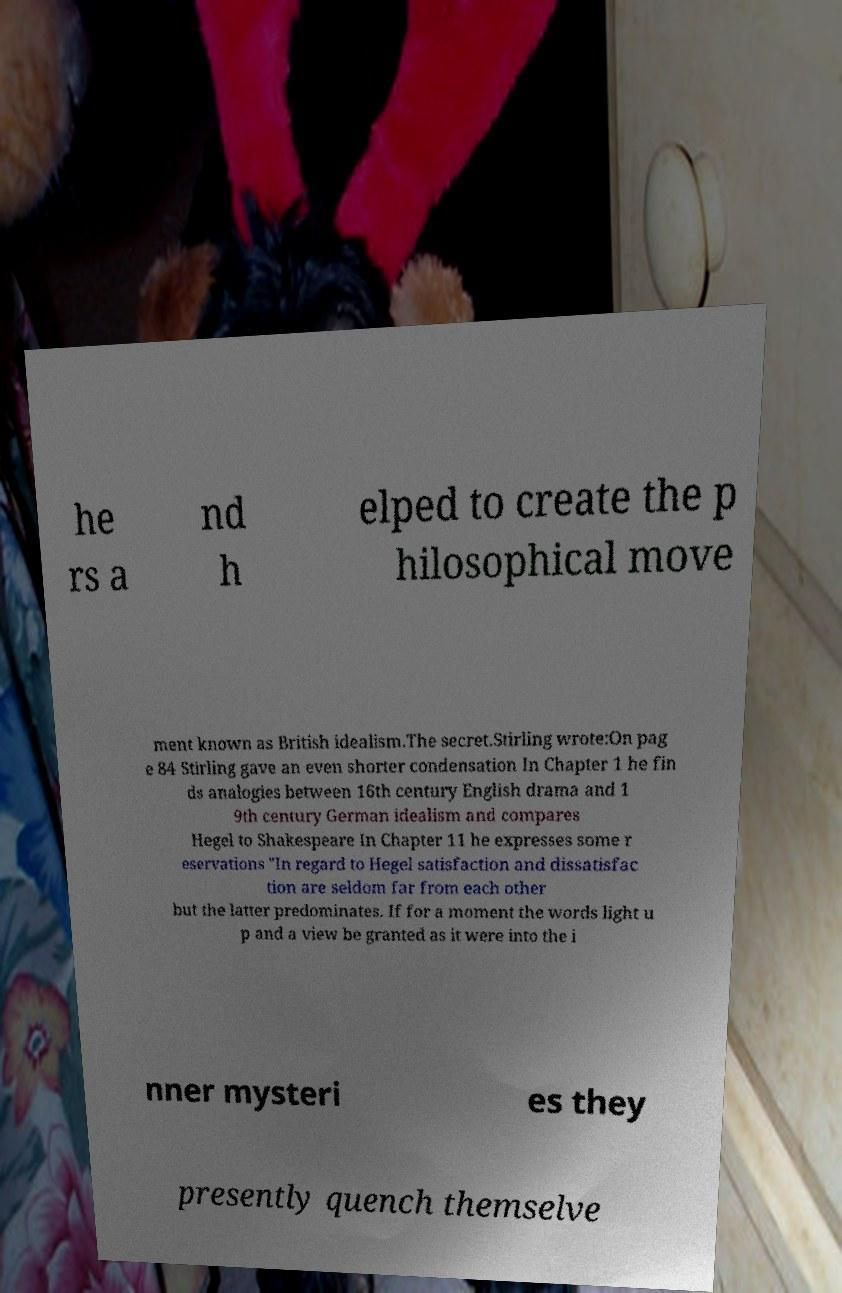What messages or text are displayed in this image? I need them in a readable, typed format. he rs a nd h elped to create the p hilosophical move ment known as British idealism.The secret.Stirling wrote:On pag e 84 Stirling gave an even shorter condensation In Chapter 1 he fin ds analogies between 16th century English drama and 1 9th century German idealism and compares Hegel to Shakespeare In Chapter 11 he expresses some r eservations "In regard to Hegel satisfaction and dissatisfac tion are seldom far from each other but the latter predominates. If for a moment the words light u p and a view be granted as it were into the i nner mysteri es they presently quench themselve 